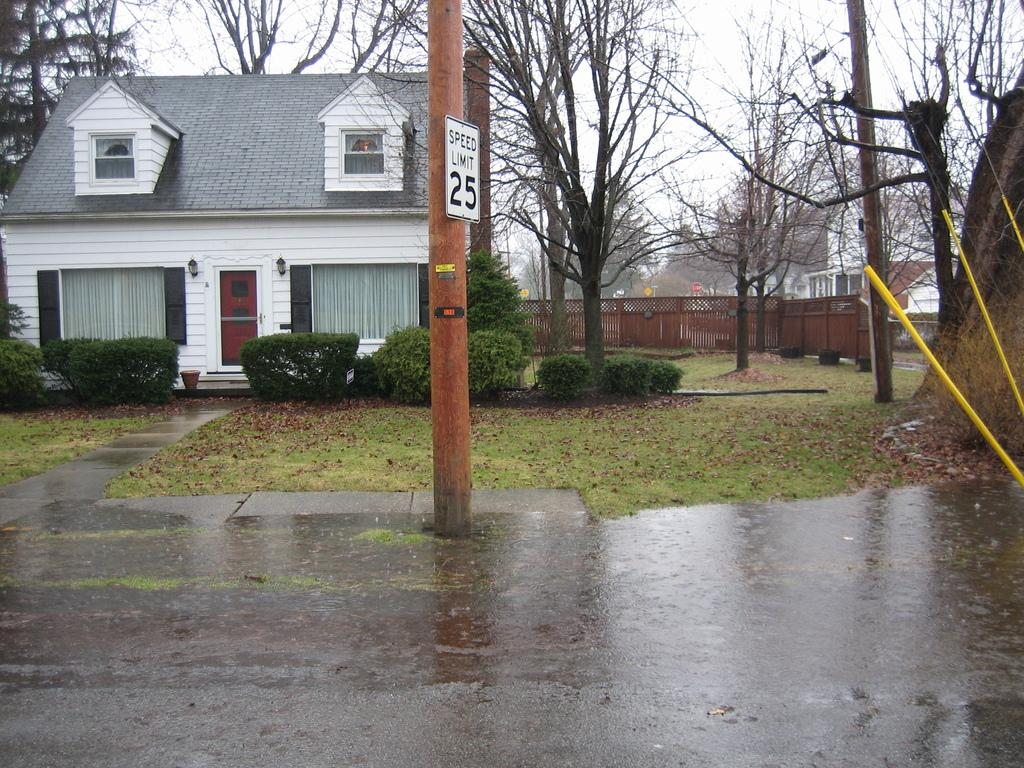What type of structure is visible in the image? There is a house in the image. Where are the plants located in the image? The plants are in the left corner of the image. What can be seen in the background of the image? There are dried trees and buildings in the background of the image. Are there any other objects visible in the background? Yes, there are other objects present in the background of the image. What type of grape is being used as a decoration on the house in the image? There is no grape present in the image, nor is it being used as a decoration on the house. 